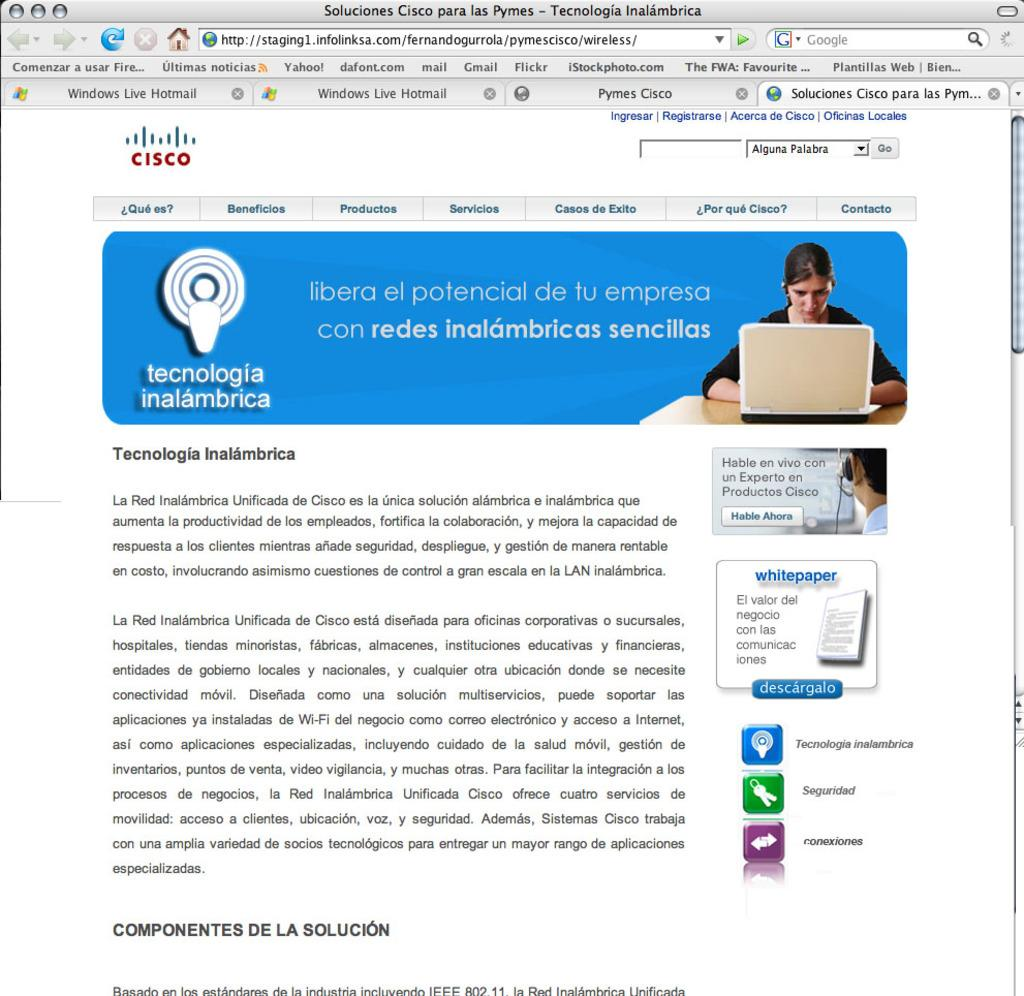What is the main subject of the image? The main subject of the image is a picture of a web page. Are there any people visible in the image? Yes, there are people on the right side of the image. What else can be seen in the image besides the web page and people? There is text visible in the image. What type of cactus is featured in the web page image? There is no cactus present in the image, as the main subject is a web page. 